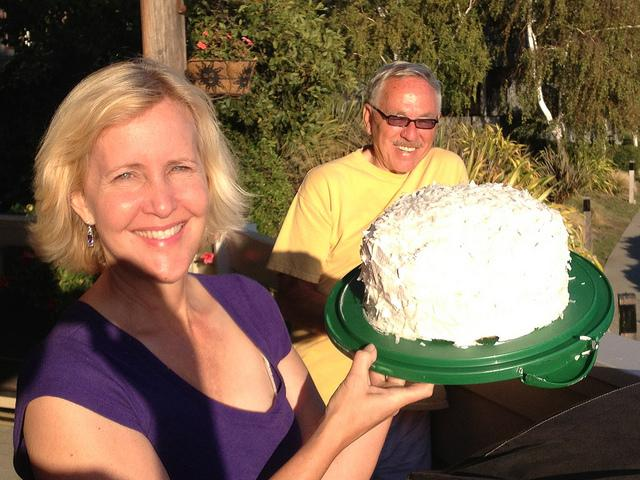The frosting is probably made from what? sugar 